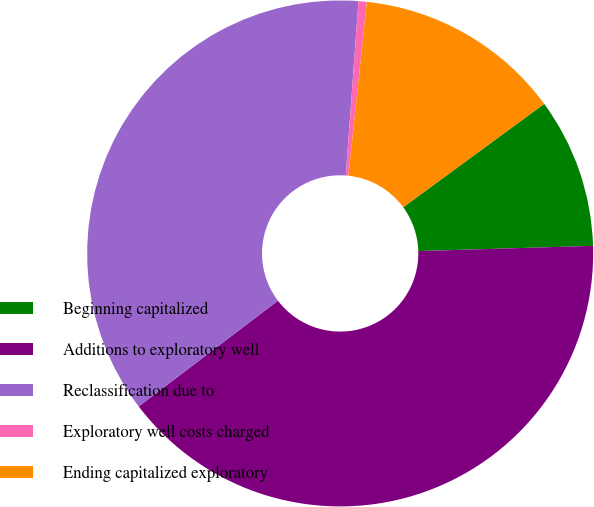Convert chart. <chart><loc_0><loc_0><loc_500><loc_500><pie_chart><fcel>Beginning capitalized<fcel>Additions to exploratory well<fcel>Reclassification due to<fcel>Exploratory well costs charged<fcel>Ending capitalized exploratory<nl><fcel>9.59%<fcel>40.14%<fcel>36.49%<fcel>0.53%<fcel>13.25%<nl></chart> 